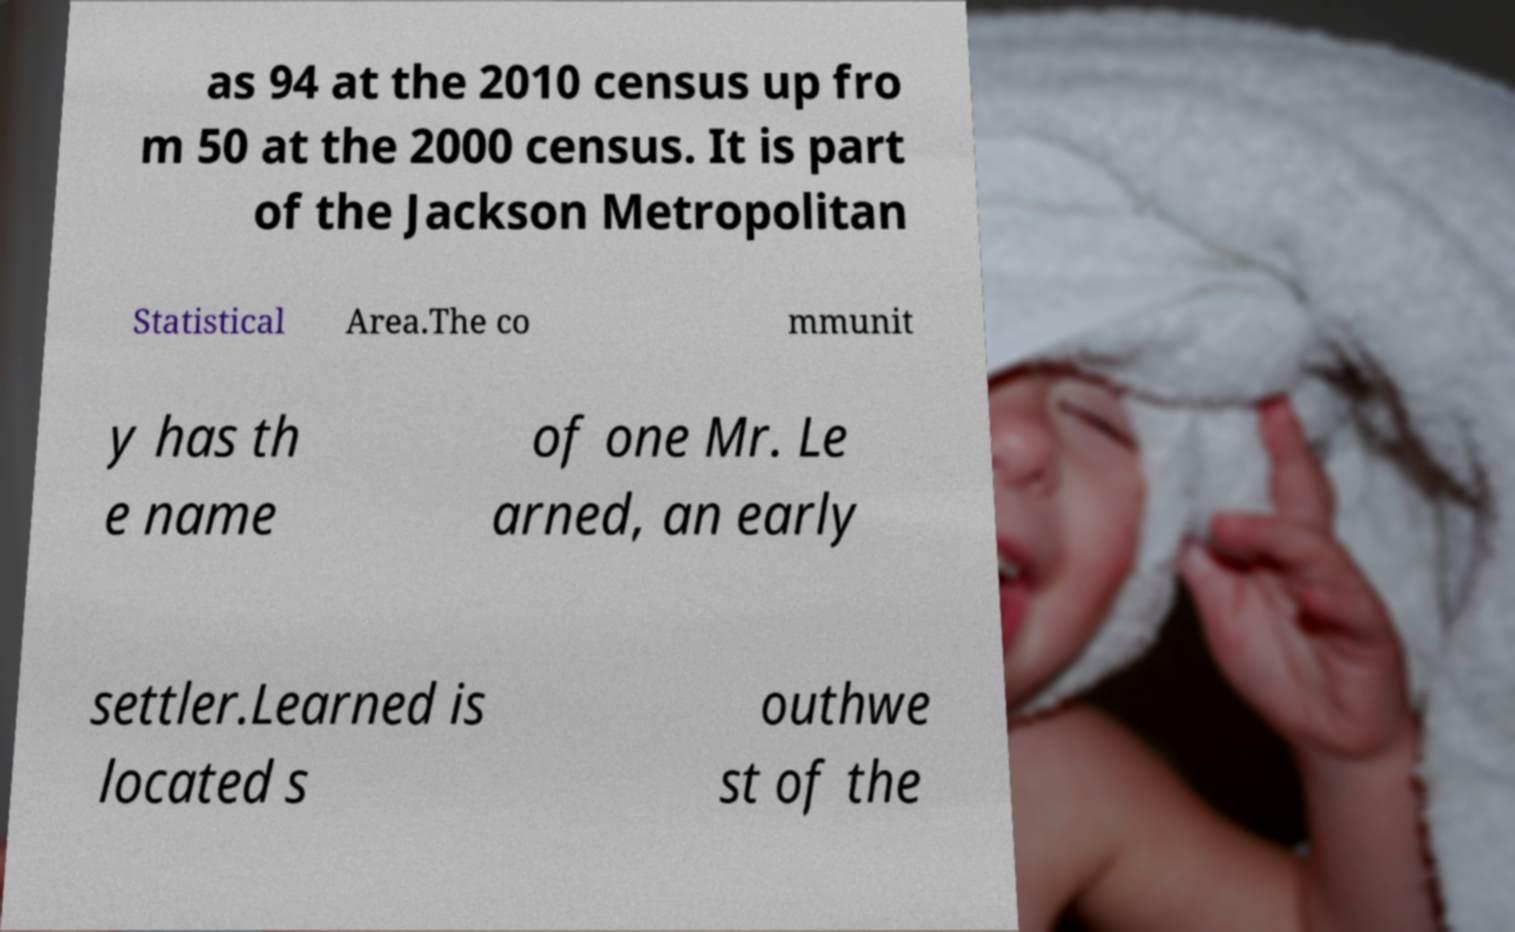I need the written content from this picture converted into text. Can you do that? as 94 at the 2010 census up fro m 50 at the 2000 census. It is part of the Jackson Metropolitan Statistical Area.The co mmunit y has th e name of one Mr. Le arned, an early settler.Learned is located s outhwe st of the 